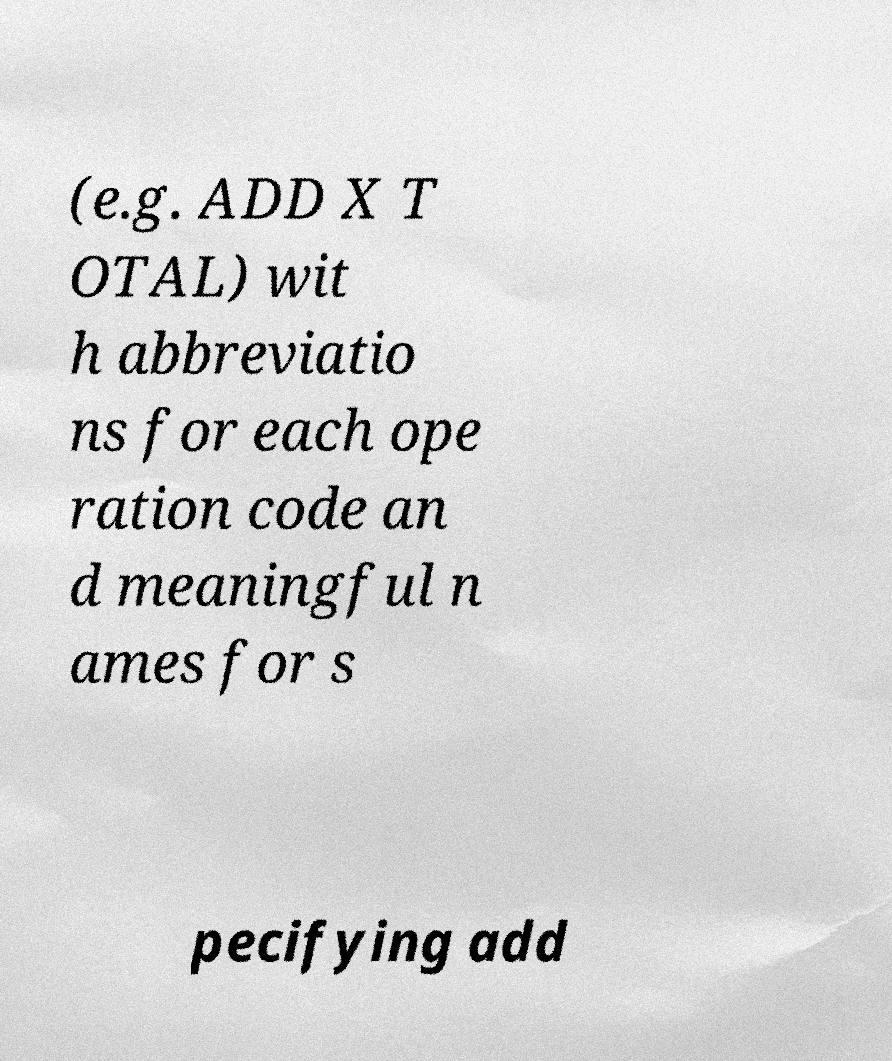What messages or text are displayed in this image? I need them in a readable, typed format. (e.g. ADD X T OTAL) wit h abbreviatio ns for each ope ration code an d meaningful n ames for s pecifying add 